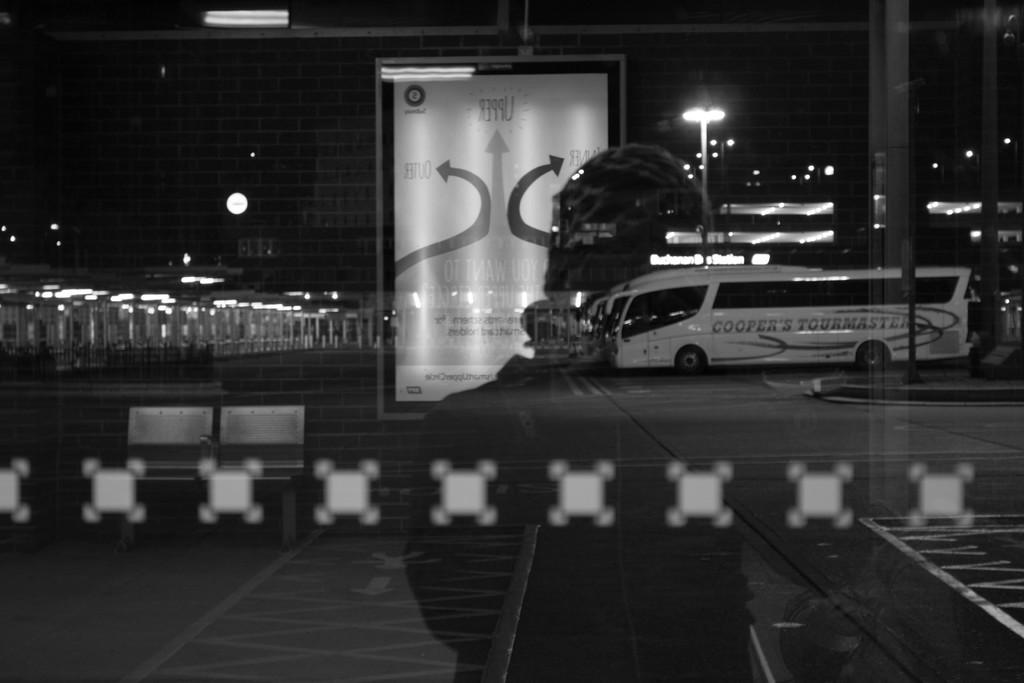What is the color scheme of the image? The image is black and white. What object is visible in the image that is typically used for drinking? There is a glass in the image. What can be seen through the glass in the image? A person's reflection is visible through the glass. What is the large, flat object in the image? There is a board in the image. What mode of transportation is present in the image? A bus is present in the image. What type of structures are visible in the image? There are buildings in the image. What surface can vehicles travel on in the image? A road is visible in the image. What type of illumination is present in the image? Lights are present in the image. What type of instrument is being played by the person in the image? There is no person playing an instrument in the image. What time of day is it in the image, based on the hour? The image is black and white, so it is not possible to determine the time of day based on the hour. 